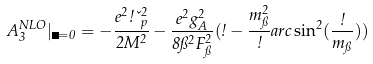Convert formula to latex. <formula><loc_0><loc_0><loc_500><loc_500>A _ { 3 } ^ { N L O } | _ { \Theta = 0 } = - \frac { e ^ { 2 } \omega \kappa _ { p } ^ { 2 } } { 2 M ^ { 2 } } - \frac { e ^ { 2 } g _ { A } ^ { 2 } } { 8 \pi ^ { 2 } F _ { \pi } ^ { 2 } } ( \omega - \frac { m _ { \pi } ^ { 2 } } { \omega } a r c \sin ^ { 2 } ( \frac { \omega } { m _ { \pi } } ) )</formula> 